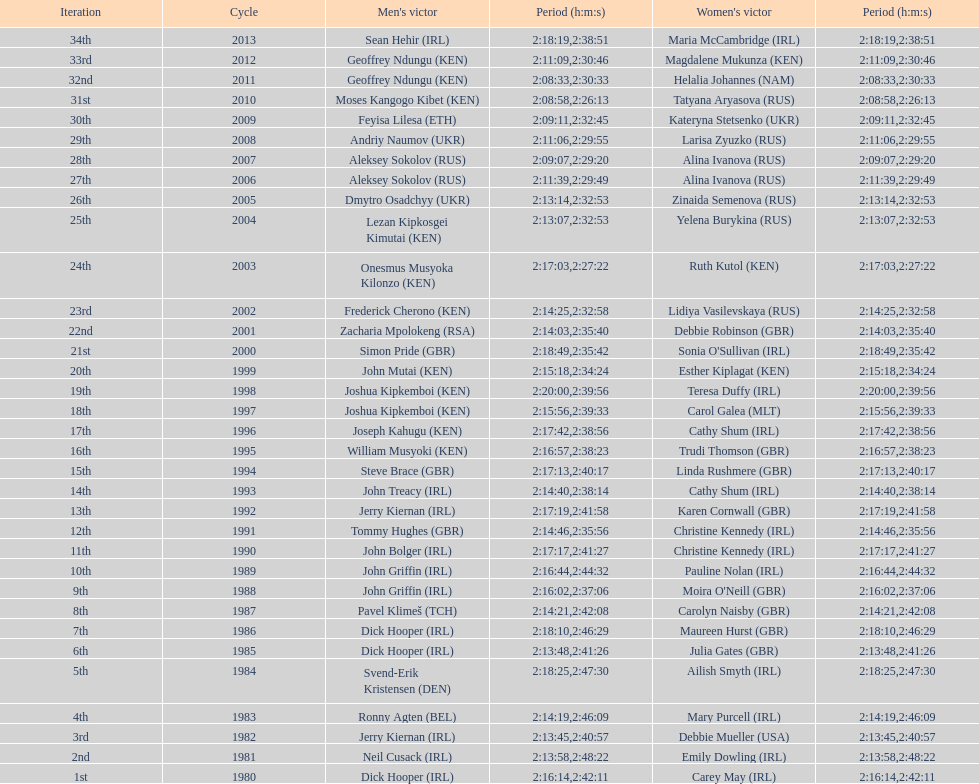Who had the most amount of time out of all the runners? Maria McCambridge (IRL). 